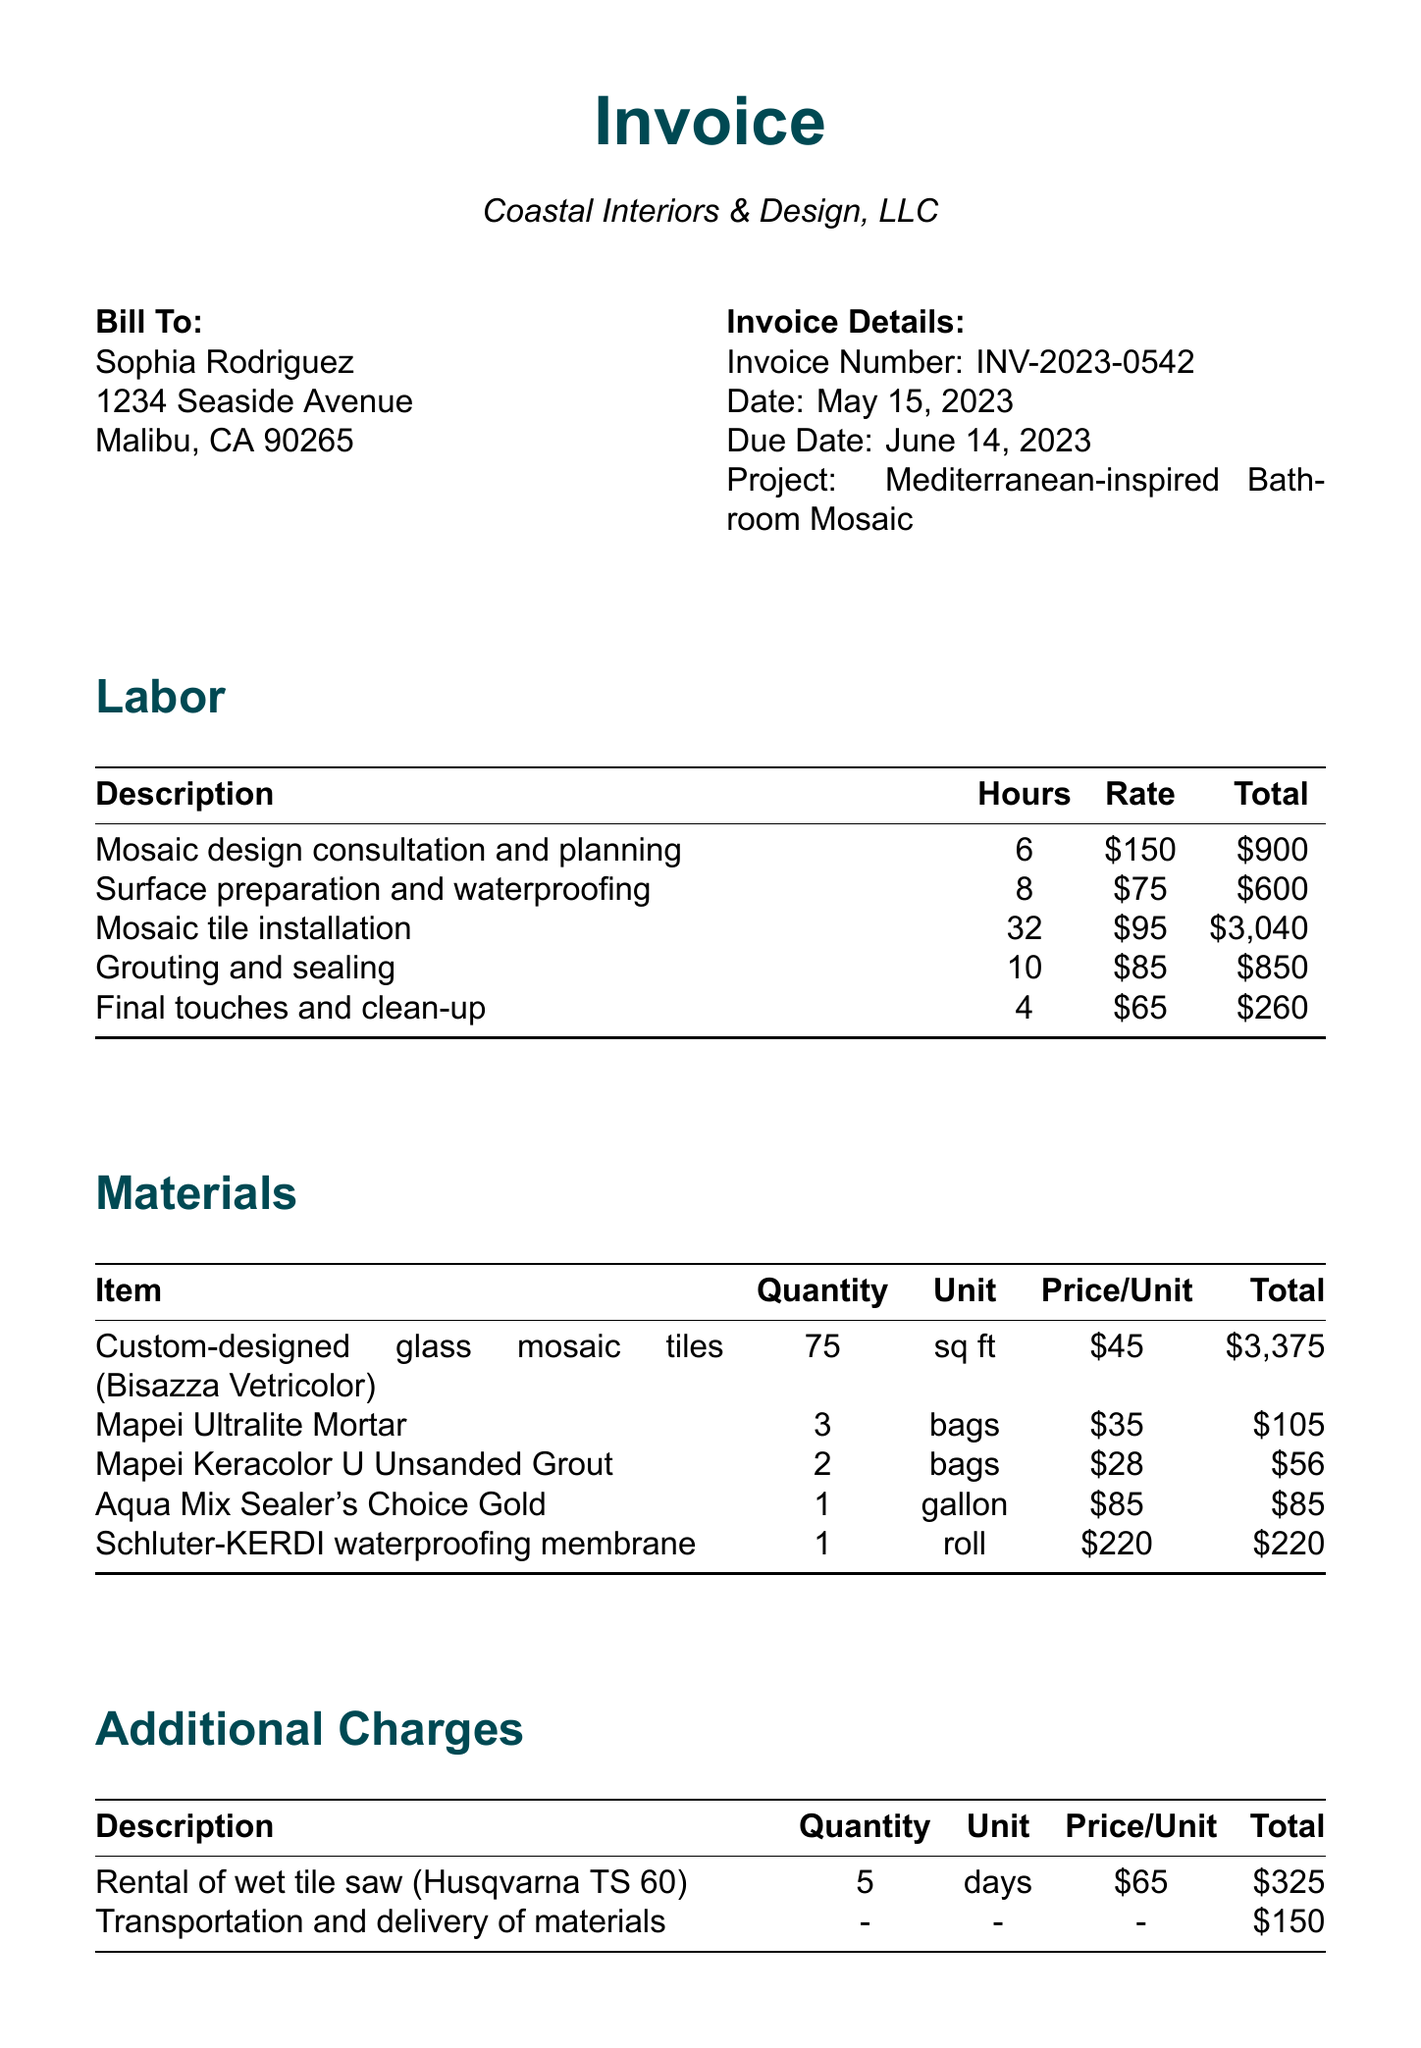What is the invoice number? The invoice number is prominently displayed in the invoice details section.
Answer: INV-2023-0542 Who is the client? The client's name is listed under the bill-to section of the invoice.
Answer: Sophia Rodriguez What is the total amount due? The total amount due is the aggregate of all subtotals in the invoice.
Answer: $9,966 How many hours were spent on mosaic tile installation? The hours for mosaic tile installation are listed in the labor breakdown section.
Answer: 32 What is the unit price for the custom-designed glass mosaic tiles? The price per unit for the mosaic tiles is provided in the materials breakdown section.
Answer: $45 What is the subtotal for labor? The subtotal for labor is combined in the financial summary at the bottom of the invoice.
Answer: $5,650 What additional charge is listed for the rental of a tile saw? The specific additional charge for renting equipment is mentioned under additional charges.
Answer: $325 When is payment due? The due date for payment is clearly stated in the invoice details.
Answer: June 14, 2023 What is the client’s address? The invoice includes the client's address in the bill-to section.
Answer: 1234 Seaside Avenue, Malibu, CA 90265 